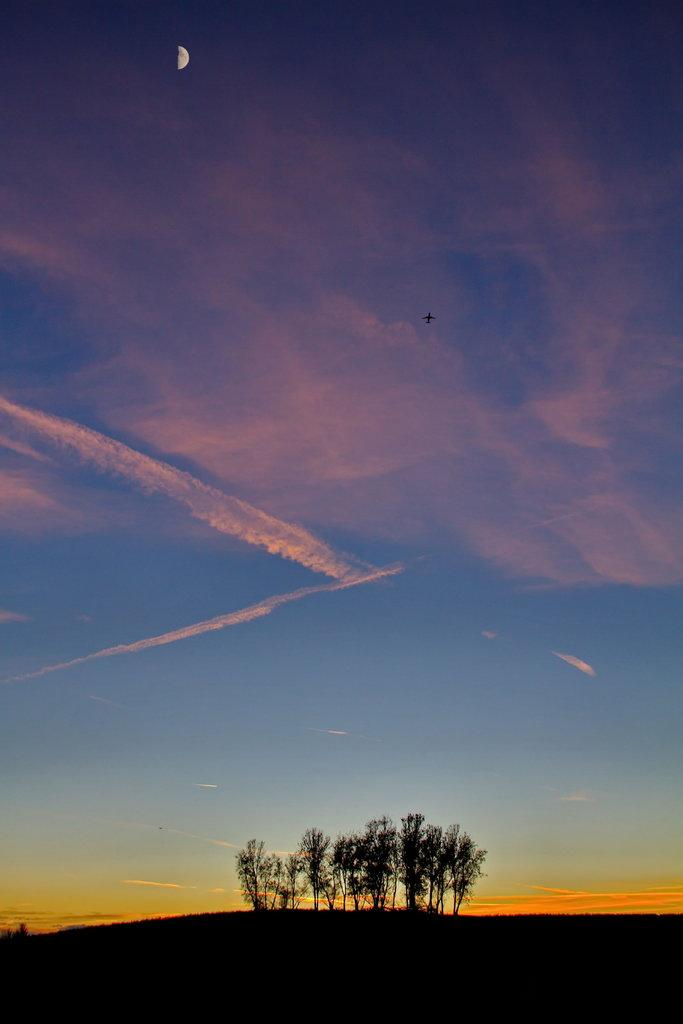What type of vegetation can be seen in the image? There are trees in the image. What is the condition of the sky in the image? The sky is clear in the image. What celestial body is visible in the sky? There is a moon visible in the sky. What type of show is being performed in the image? There is no show being performed in the image; it features trees, a clear sky, and a visible moon. Can you tell me how many spades are present in the image? There are no spades present in the image. 